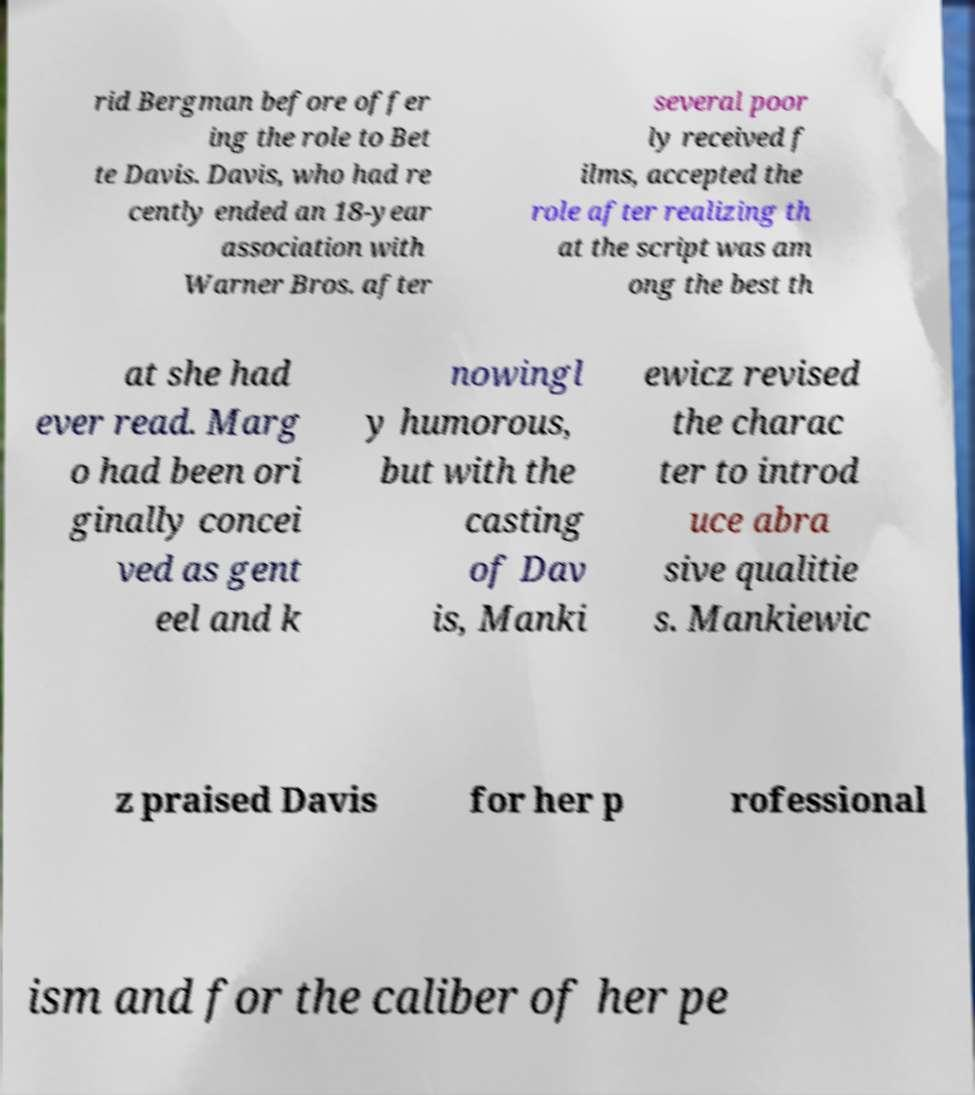Can you read and provide the text displayed in the image?This photo seems to have some interesting text. Can you extract and type it out for me? rid Bergman before offer ing the role to Bet te Davis. Davis, who had re cently ended an 18-year association with Warner Bros. after several poor ly received f ilms, accepted the role after realizing th at the script was am ong the best th at she had ever read. Marg o had been ori ginally concei ved as gent eel and k nowingl y humorous, but with the casting of Dav is, Manki ewicz revised the charac ter to introd uce abra sive qualitie s. Mankiewic z praised Davis for her p rofessional ism and for the caliber of her pe 